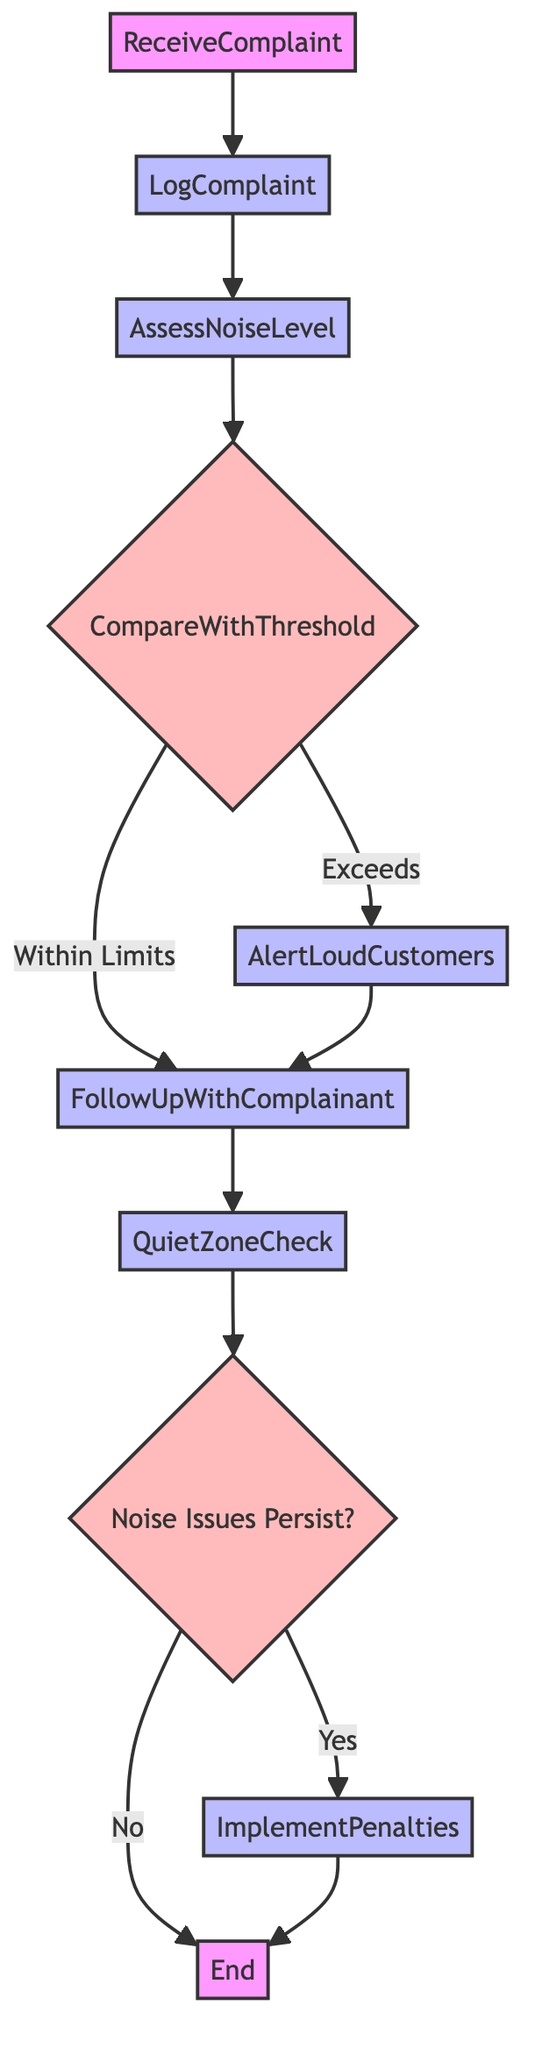What is the first step in the process? The first step in the process is "ReceiveComplaint," where a noise complaint is submitted by a customer.
Answer: ReceiveComplaint How many steps are there in total? Counting each unique labeled step in the diagram, there are a total of 8 steps including decisions.
Answer: 8 What happens if the noise level exceeds the threshold? If the noise level exceeds the threshold, the next action taken is to "AlertLoudCustomers" to lower their volume.
Answer: AlertLoudCustomers What does the diagram check after following up with the complainant? After following up with the complainant, the next check is the "QuietZoneCheck" to ensure signage is displayed.
Answer: QuietZoneCheck What is implemented if noise issues persist? If noise issues persist, the action taken is to "ImplementPenalties" for repeat offenders.
Answer: ImplementPenalties Which step comes after assessing the noise level? After assessing the noise level, the next step is to "CompareWithThreshold" to see if the level is acceptable.
Answer: CompareWithThreshold Is "FollowUpWithComplainant" connected to any other step besides "CompareWithThreshold"? Yes, "FollowUpWithComplainant" connects to "QuietZoneCheck" as the next step after it is complete.
Answer: Yes What is the outcome if there are no noise issues after the check? If there are no noise issues after the check, the process ends with "End."
Answer: End What action is taken before the complaint is logged? Before the complaint is logged, the action taken is to "ReceiveComplaint" from the customer.
Answer: ReceiveComplaint 